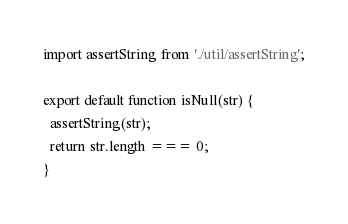<code> <loc_0><loc_0><loc_500><loc_500><_JavaScript_>import assertString from './util/assertString';

export default function isNull(str) {
  assertString(str);
  return str.length === 0;
}
</code> 